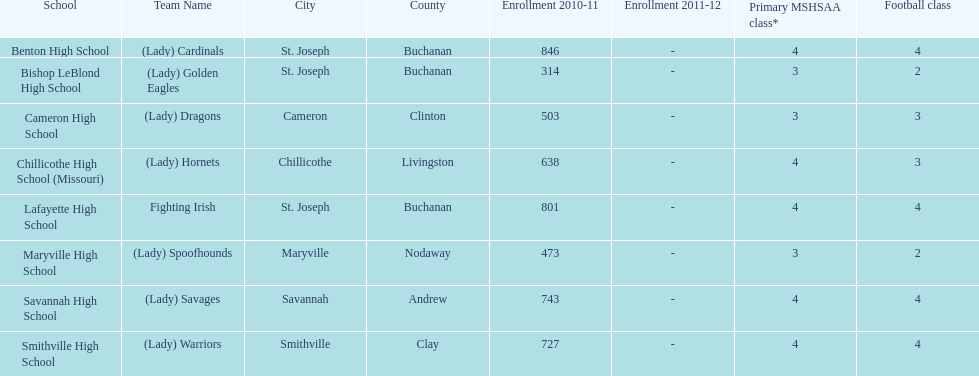Which schools are in the same town as bishop leblond? Benton High School, Lafayette High School. 